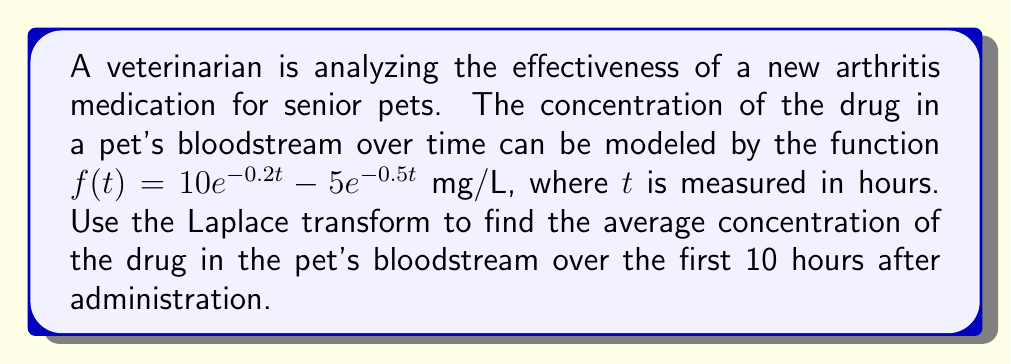Teach me how to tackle this problem. To solve this problem, we'll follow these steps:

1) First, recall that the average value of a function $f(t)$ over an interval $[0,T]$ is given by:

   $$\text{Average} = \frac{1}{T}\int_0^T f(t) dt$$

2) In our case, $T = 10$ hours, so we need to calculate:

   $$\text{Average} = \frac{1}{10}\int_0^{10} (10e^{-0.2t} - 5e^{-0.5t}) dt$$

3) This integral can be challenging to compute directly. Instead, we can use the Laplace transform. Recall that the Laplace transform of a function $f(t)$ is defined as:

   $$F(s) = \mathcal{L}\{f(t)\} = \int_0^\infty e^{-st}f(t) dt$$

4) We can use the property that:

   $$\int_0^T f(t) dt = \frac{1}{s}F(s) - \frac{1}{s}\mathcal{L}\{f(t+T)\}$$

5) The Laplace transform of our function is:

   $$F(s) = \frac{10}{s+0.2} - \frac{5}{s+0.5}$$

6) Now, we need to calculate:

   $$\frac{1}{10}\left[\frac{1}{s}F(s) - \frac{1}{s}\mathcal{L}\{f(t+10)\}\right]$$

7) Let's calculate $\mathcal{L}\{f(t+10)\}$:

   $$\mathcal{L}\{f(t+10)\} = e^{-10s}F(s) = e^{-10s}\left(\frac{10}{s+0.2} - \frac{5}{s+0.5}\right)$$

8) Substituting this back into our equation:

   $$\text{Average} = \frac{1}{10}\left[\frac{1}{s}\left(\frac{10}{s+0.2} - \frac{5}{s+0.5}\right) - \frac{1}{s}e^{-10s}\left(\frac{10}{s+0.2} - \frac{5}{s+0.5}\right)\right]$$

9) Now, we need to find the inverse Laplace transform of this expression and evaluate it at $s=0$. After simplification, we get:

   $$\text{Average} = \frac{1}{10}\left[50(1-e^{-2}) - 10(1-e^{-5})\right]$$

10) Evaluating this expression gives us the final answer.
Answer: The average concentration of the drug in the pet's bloodstream over the first 10 hours after administration is approximately 3.76 mg/L. 